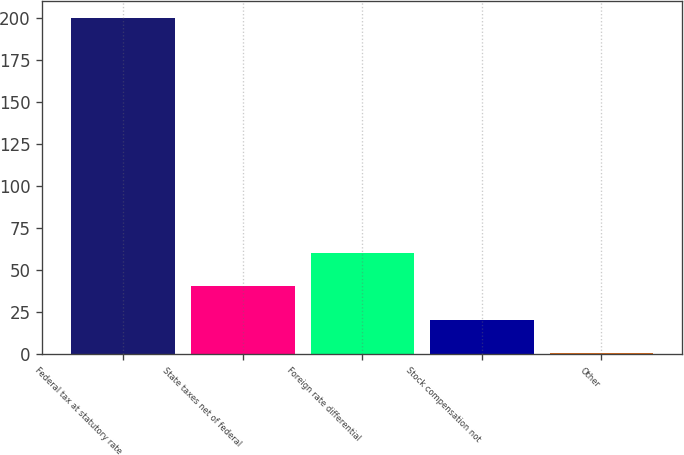<chart> <loc_0><loc_0><loc_500><loc_500><bar_chart><fcel>Federal tax at statutory rate<fcel>State taxes net of federal<fcel>Foreign rate differential<fcel>Stock compensation not<fcel>Other<nl><fcel>200.3<fcel>40.7<fcel>60.65<fcel>20.75<fcel>0.8<nl></chart> 